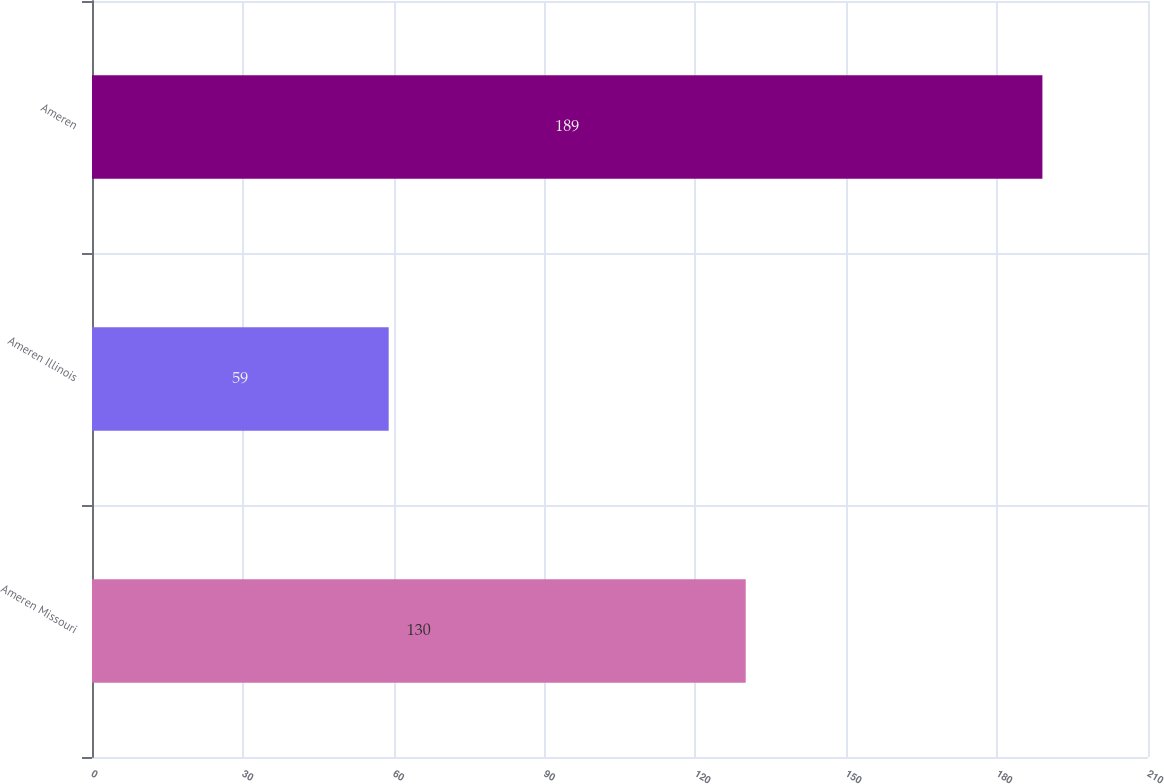Convert chart. <chart><loc_0><loc_0><loc_500><loc_500><bar_chart><fcel>Ameren Missouri<fcel>Ameren Illinois<fcel>Ameren<nl><fcel>130<fcel>59<fcel>189<nl></chart> 